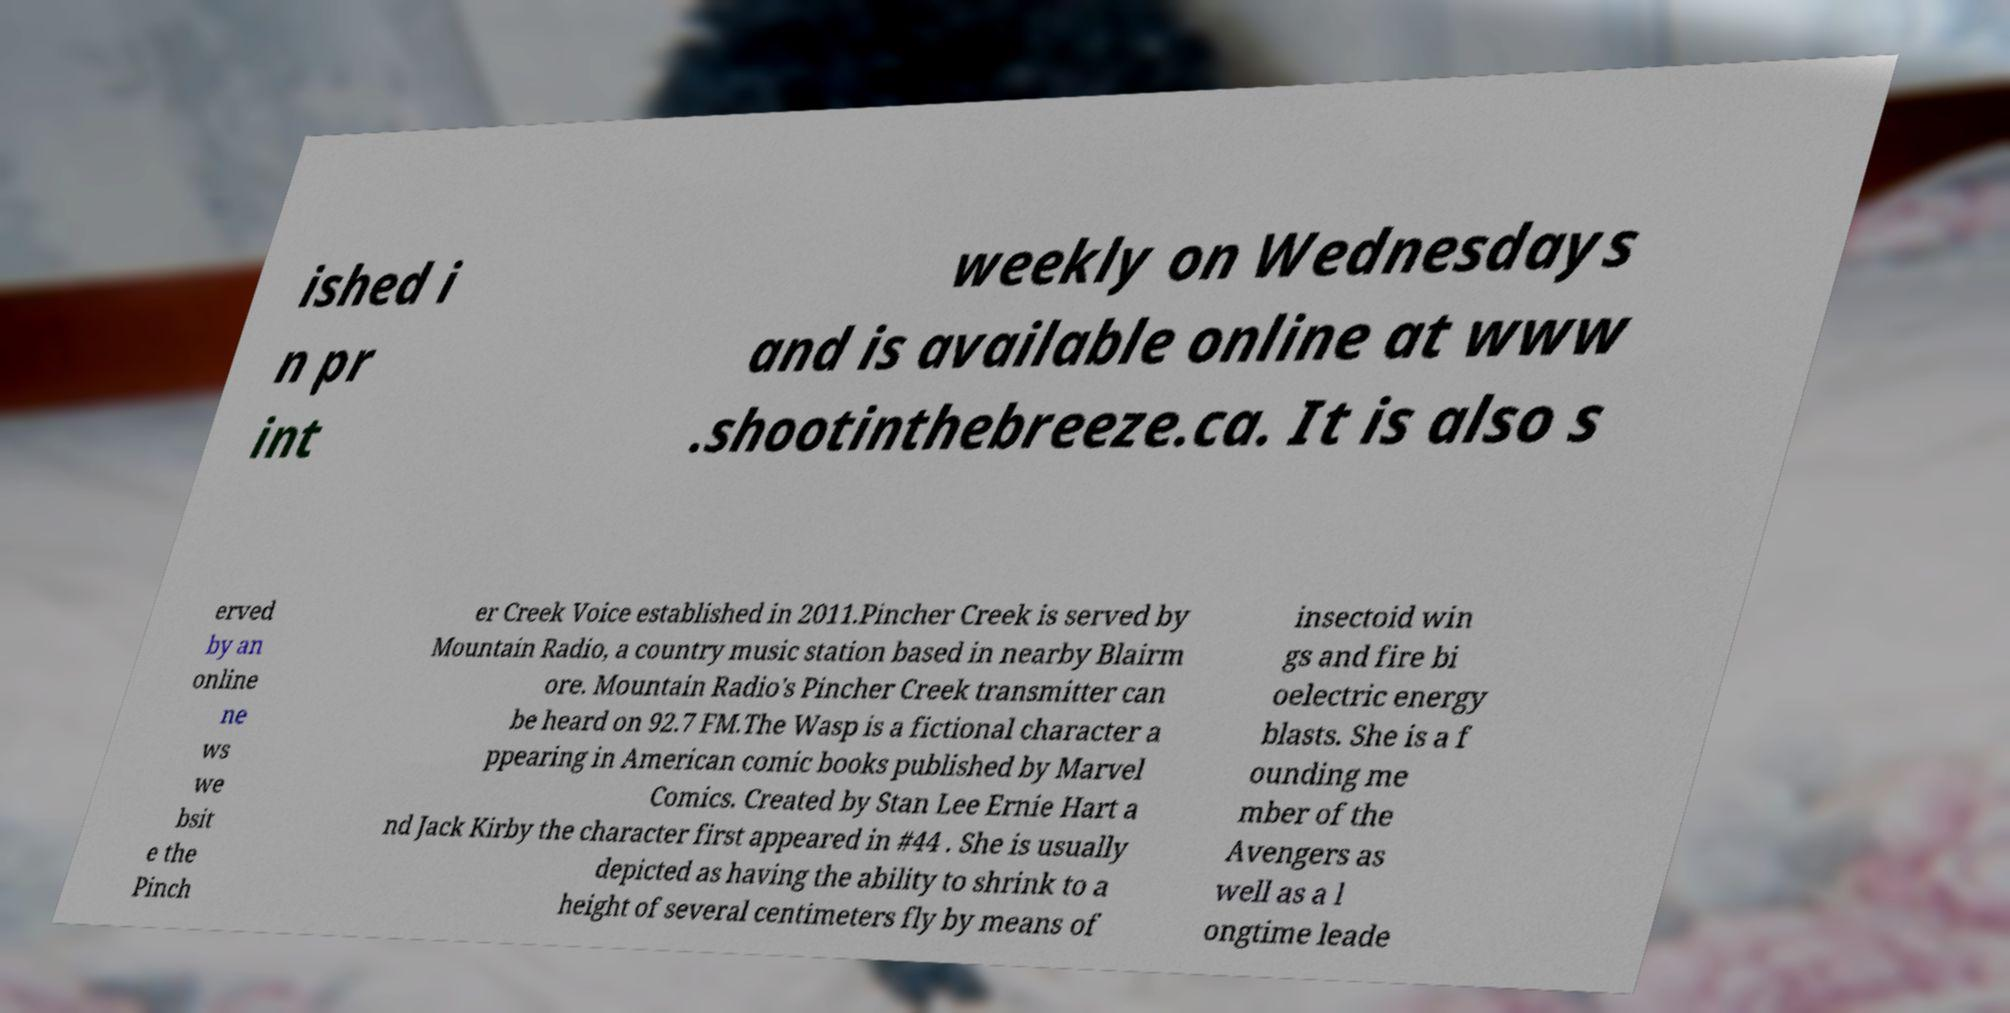Could you extract and type out the text from this image? ished i n pr int weekly on Wednesdays and is available online at www .shootinthebreeze.ca. It is also s erved by an online ne ws we bsit e the Pinch er Creek Voice established in 2011.Pincher Creek is served by Mountain Radio, a country music station based in nearby Blairm ore. Mountain Radio's Pincher Creek transmitter can be heard on 92.7 FM.The Wasp is a fictional character a ppearing in American comic books published by Marvel Comics. Created by Stan Lee Ernie Hart a nd Jack Kirby the character first appeared in #44 . She is usually depicted as having the ability to shrink to a height of several centimeters fly by means of insectoid win gs and fire bi oelectric energy blasts. She is a f ounding me mber of the Avengers as well as a l ongtime leade 